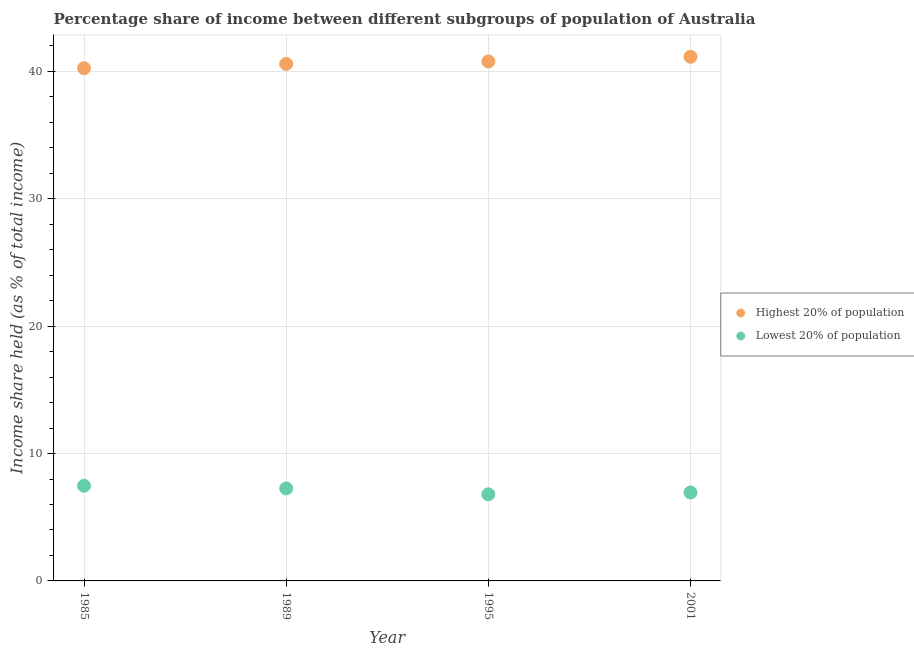How many different coloured dotlines are there?
Provide a succinct answer. 2. What is the income share held by highest 20% of the population in 1995?
Your response must be concise. 40.78. Across all years, what is the maximum income share held by highest 20% of the population?
Provide a short and direct response. 41.15. Across all years, what is the minimum income share held by highest 20% of the population?
Offer a terse response. 40.25. In which year was the income share held by lowest 20% of the population maximum?
Ensure brevity in your answer.  1985. In which year was the income share held by lowest 20% of the population minimum?
Offer a very short reply. 1995. What is the total income share held by highest 20% of the population in the graph?
Offer a very short reply. 162.77. What is the difference between the income share held by lowest 20% of the population in 1985 and that in 2001?
Ensure brevity in your answer.  0.53. What is the difference between the income share held by highest 20% of the population in 1989 and the income share held by lowest 20% of the population in 2001?
Your response must be concise. 33.65. What is the average income share held by lowest 20% of the population per year?
Provide a short and direct response. 7.12. In the year 1985, what is the difference between the income share held by lowest 20% of the population and income share held by highest 20% of the population?
Keep it short and to the point. -32.78. In how many years, is the income share held by lowest 20% of the population greater than 24 %?
Provide a succinct answer. 0. What is the ratio of the income share held by lowest 20% of the population in 1989 to that in 1995?
Your answer should be very brief. 1.07. Is the difference between the income share held by highest 20% of the population in 1995 and 2001 greater than the difference between the income share held by lowest 20% of the population in 1995 and 2001?
Offer a terse response. No. What is the difference between the highest and the second highest income share held by lowest 20% of the population?
Give a very brief answer. 0.21. What is the difference between the highest and the lowest income share held by highest 20% of the population?
Give a very brief answer. 0.9. Is the sum of the income share held by highest 20% of the population in 1989 and 1995 greater than the maximum income share held by lowest 20% of the population across all years?
Offer a terse response. Yes. Is the income share held by lowest 20% of the population strictly greater than the income share held by highest 20% of the population over the years?
Your answer should be very brief. No. Is the income share held by highest 20% of the population strictly less than the income share held by lowest 20% of the population over the years?
Your answer should be very brief. No. How many dotlines are there?
Keep it short and to the point. 2. Are the values on the major ticks of Y-axis written in scientific E-notation?
Offer a very short reply. No. Does the graph contain grids?
Provide a succinct answer. Yes. Where does the legend appear in the graph?
Provide a short and direct response. Center right. How many legend labels are there?
Provide a short and direct response. 2. What is the title of the graph?
Ensure brevity in your answer.  Percentage share of income between different subgroups of population of Australia. Does "Girls" appear as one of the legend labels in the graph?
Offer a very short reply. No. What is the label or title of the Y-axis?
Your answer should be very brief. Income share held (as % of total income). What is the Income share held (as % of total income) in Highest 20% of population in 1985?
Make the answer very short. 40.25. What is the Income share held (as % of total income) in Lowest 20% of population in 1985?
Your response must be concise. 7.47. What is the Income share held (as % of total income) of Highest 20% of population in 1989?
Provide a succinct answer. 40.59. What is the Income share held (as % of total income) in Lowest 20% of population in 1989?
Offer a very short reply. 7.26. What is the Income share held (as % of total income) in Highest 20% of population in 1995?
Make the answer very short. 40.78. What is the Income share held (as % of total income) of Lowest 20% of population in 1995?
Your response must be concise. 6.8. What is the Income share held (as % of total income) in Highest 20% of population in 2001?
Give a very brief answer. 41.15. What is the Income share held (as % of total income) of Lowest 20% of population in 2001?
Give a very brief answer. 6.94. Across all years, what is the maximum Income share held (as % of total income) in Highest 20% of population?
Keep it short and to the point. 41.15. Across all years, what is the maximum Income share held (as % of total income) of Lowest 20% of population?
Give a very brief answer. 7.47. Across all years, what is the minimum Income share held (as % of total income) of Highest 20% of population?
Keep it short and to the point. 40.25. Across all years, what is the minimum Income share held (as % of total income) of Lowest 20% of population?
Your answer should be compact. 6.8. What is the total Income share held (as % of total income) of Highest 20% of population in the graph?
Your answer should be compact. 162.77. What is the total Income share held (as % of total income) in Lowest 20% of population in the graph?
Make the answer very short. 28.47. What is the difference between the Income share held (as % of total income) of Highest 20% of population in 1985 and that in 1989?
Your answer should be compact. -0.34. What is the difference between the Income share held (as % of total income) in Lowest 20% of population in 1985 and that in 1989?
Offer a terse response. 0.21. What is the difference between the Income share held (as % of total income) of Highest 20% of population in 1985 and that in 1995?
Offer a very short reply. -0.53. What is the difference between the Income share held (as % of total income) of Lowest 20% of population in 1985 and that in 1995?
Offer a terse response. 0.67. What is the difference between the Income share held (as % of total income) in Lowest 20% of population in 1985 and that in 2001?
Offer a very short reply. 0.53. What is the difference between the Income share held (as % of total income) of Highest 20% of population in 1989 and that in 1995?
Provide a short and direct response. -0.19. What is the difference between the Income share held (as % of total income) of Lowest 20% of population in 1989 and that in 1995?
Your response must be concise. 0.46. What is the difference between the Income share held (as % of total income) in Highest 20% of population in 1989 and that in 2001?
Provide a succinct answer. -0.56. What is the difference between the Income share held (as % of total income) of Lowest 20% of population in 1989 and that in 2001?
Offer a terse response. 0.32. What is the difference between the Income share held (as % of total income) of Highest 20% of population in 1995 and that in 2001?
Ensure brevity in your answer.  -0.37. What is the difference between the Income share held (as % of total income) in Lowest 20% of population in 1995 and that in 2001?
Your answer should be compact. -0.14. What is the difference between the Income share held (as % of total income) of Highest 20% of population in 1985 and the Income share held (as % of total income) of Lowest 20% of population in 1989?
Provide a short and direct response. 32.99. What is the difference between the Income share held (as % of total income) in Highest 20% of population in 1985 and the Income share held (as % of total income) in Lowest 20% of population in 1995?
Give a very brief answer. 33.45. What is the difference between the Income share held (as % of total income) of Highest 20% of population in 1985 and the Income share held (as % of total income) of Lowest 20% of population in 2001?
Provide a short and direct response. 33.31. What is the difference between the Income share held (as % of total income) of Highest 20% of population in 1989 and the Income share held (as % of total income) of Lowest 20% of population in 1995?
Your response must be concise. 33.79. What is the difference between the Income share held (as % of total income) in Highest 20% of population in 1989 and the Income share held (as % of total income) in Lowest 20% of population in 2001?
Make the answer very short. 33.65. What is the difference between the Income share held (as % of total income) in Highest 20% of population in 1995 and the Income share held (as % of total income) in Lowest 20% of population in 2001?
Give a very brief answer. 33.84. What is the average Income share held (as % of total income) in Highest 20% of population per year?
Provide a short and direct response. 40.69. What is the average Income share held (as % of total income) of Lowest 20% of population per year?
Provide a short and direct response. 7.12. In the year 1985, what is the difference between the Income share held (as % of total income) in Highest 20% of population and Income share held (as % of total income) in Lowest 20% of population?
Provide a short and direct response. 32.78. In the year 1989, what is the difference between the Income share held (as % of total income) in Highest 20% of population and Income share held (as % of total income) in Lowest 20% of population?
Offer a terse response. 33.33. In the year 1995, what is the difference between the Income share held (as % of total income) of Highest 20% of population and Income share held (as % of total income) of Lowest 20% of population?
Provide a succinct answer. 33.98. In the year 2001, what is the difference between the Income share held (as % of total income) in Highest 20% of population and Income share held (as % of total income) in Lowest 20% of population?
Keep it short and to the point. 34.21. What is the ratio of the Income share held (as % of total income) of Highest 20% of population in 1985 to that in 1989?
Make the answer very short. 0.99. What is the ratio of the Income share held (as % of total income) of Lowest 20% of population in 1985 to that in 1989?
Provide a short and direct response. 1.03. What is the ratio of the Income share held (as % of total income) in Highest 20% of population in 1985 to that in 1995?
Make the answer very short. 0.99. What is the ratio of the Income share held (as % of total income) in Lowest 20% of population in 1985 to that in 1995?
Provide a succinct answer. 1.1. What is the ratio of the Income share held (as % of total income) of Highest 20% of population in 1985 to that in 2001?
Your response must be concise. 0.98. What is the ratio of the Income share held (as % of total income) in Lowest 20% of population in 1985 to that in 2001?
Your answer should be compact. 1.08. What is the ratio of the Income share held (as % of total income) in Highest 20% of population in 1989 to that in 1995?
Make the answer very short. 1. What is the ratio of the Income share held (as % of total income) of Lowest 20% of population in 1989 to that in 1995?
Ensure brevity in your answer.  1.07. What is the ratio of the Income share held (as % of total income) in Highest 20% of population in 1989 to that in 2001?
Keep it short and to the point. 0.99. What is the ratio of the Income share held (as % of total income) in Lowest 20% of population in 1989 to that in 2001?
Provide a short and direct response. 1.05. What is the ratio of the Income share held (as % of total income) of Lowest 20% of population in 1995 to that in 2001?
Give a very brief answer. 0.98. What is the difference between the highest and the second highest Income share held (as % of total income) in Highest 20% of population?
Offer a terse response. 0.37. What is the difference between the highest and the second highest Income share held (as % of total income) of Lowest 20% of population?
Make the answer very short. 0.21. What is the difference between the highest and the lowest Income share held (as % of total income) in Lowest 20% of population?
Make the answer very short. 0.67. 